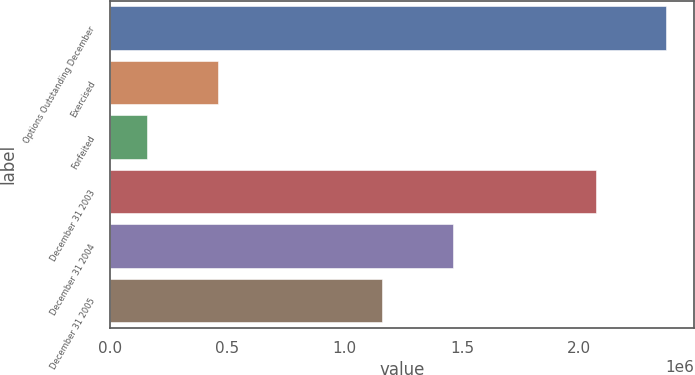<chart> <loc_0><loc_0><loc_500><loc_500><bar_chart><fcel>Options Outstanding December<fcel>Exercised<fcel>Forfeited<fcel>December 31 2003<fcel>December 31 2004<fcel>December 31 2005<nl><fcel>2.3706e+06<fcel>457901<fcel>157000<fcel>2.0697e+06<fcel>1.45949e+06<fcel>1.15859e+06<nl></chart> 